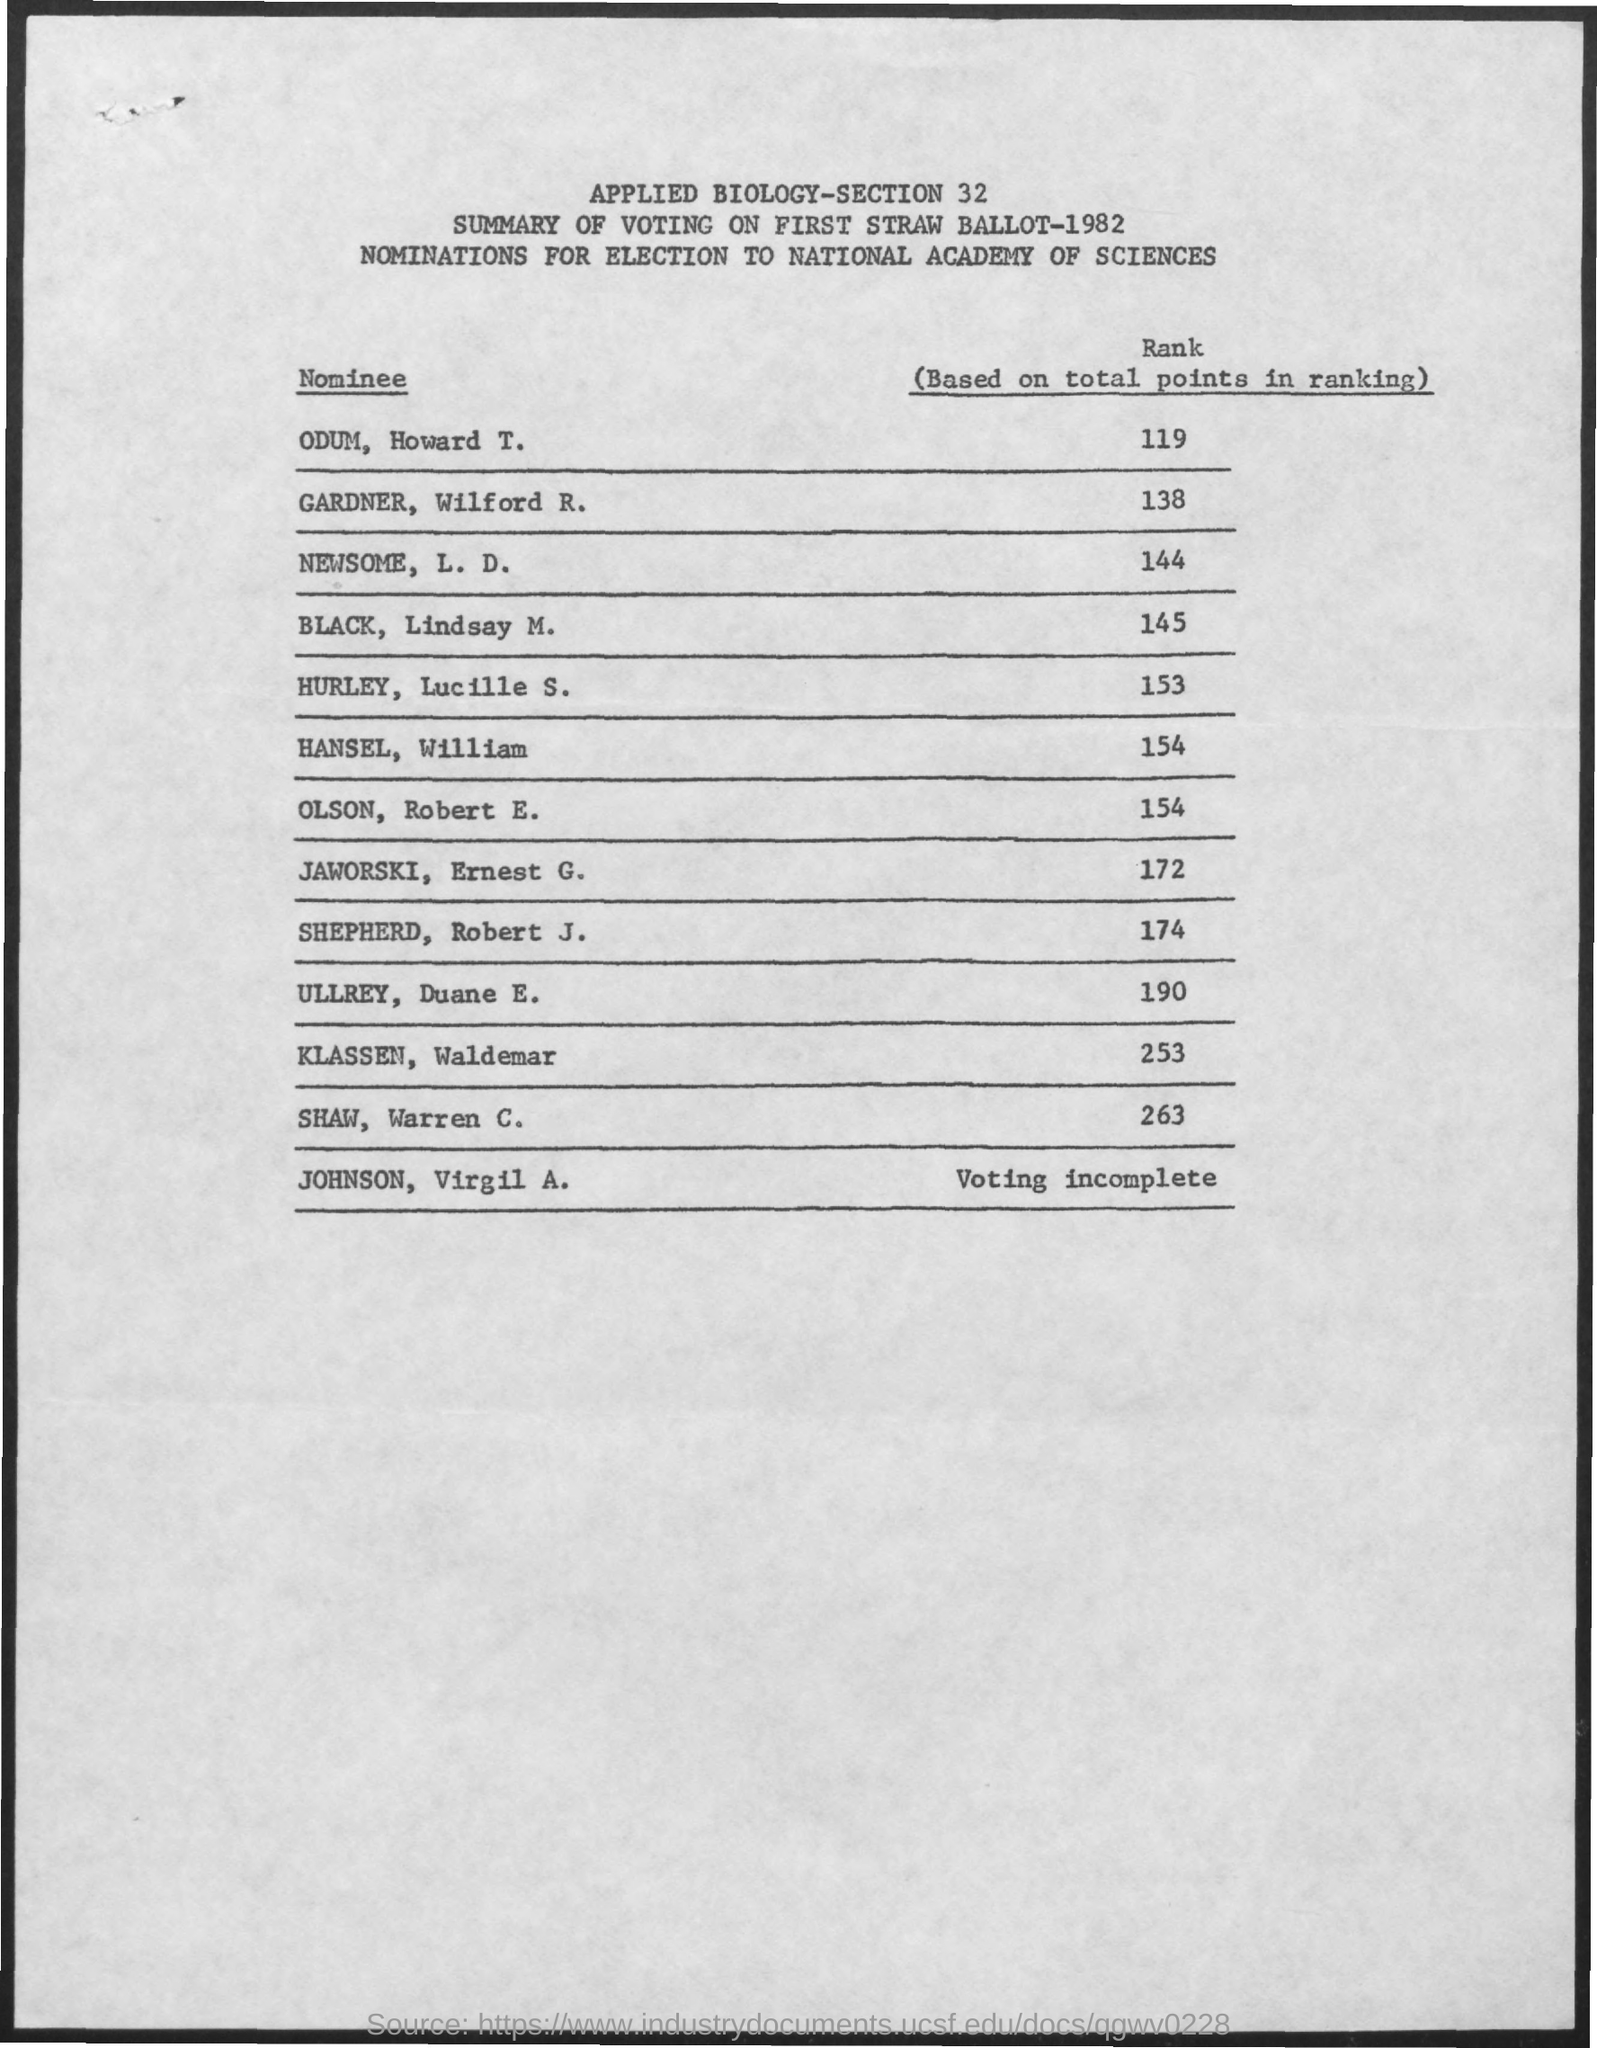Who scores the highest point?
Ensure brevity in your answer.  SHAW, Warren C. What is the nomination on?
Offer a terse response. Election to national academy of sciences. How many points did ODUM, Howard T. scored?
Your answer should be very brief. 119. Who scored 145 points?
Make the answer very short. BLACK,  Lindsay M. How many points did HURLEY, Lucille S.?
Ensure brevity in your answer.  153. What is this summary about?
Your answer should be very brief. Summary of Voting on First Straw Ballot-1982. Who scored 138 points?
Make the answer very short. Gardner, Wilford R. How many points did ULLREY, Duane E. scored?
Provide a succinct answer. 190. Who scored 174 points?
Provide a short and direct response. SHEPHERD, Robert J. Whose voting was incomplete?
Ensure brevity in your answer.  Johnson, Virgil A. 